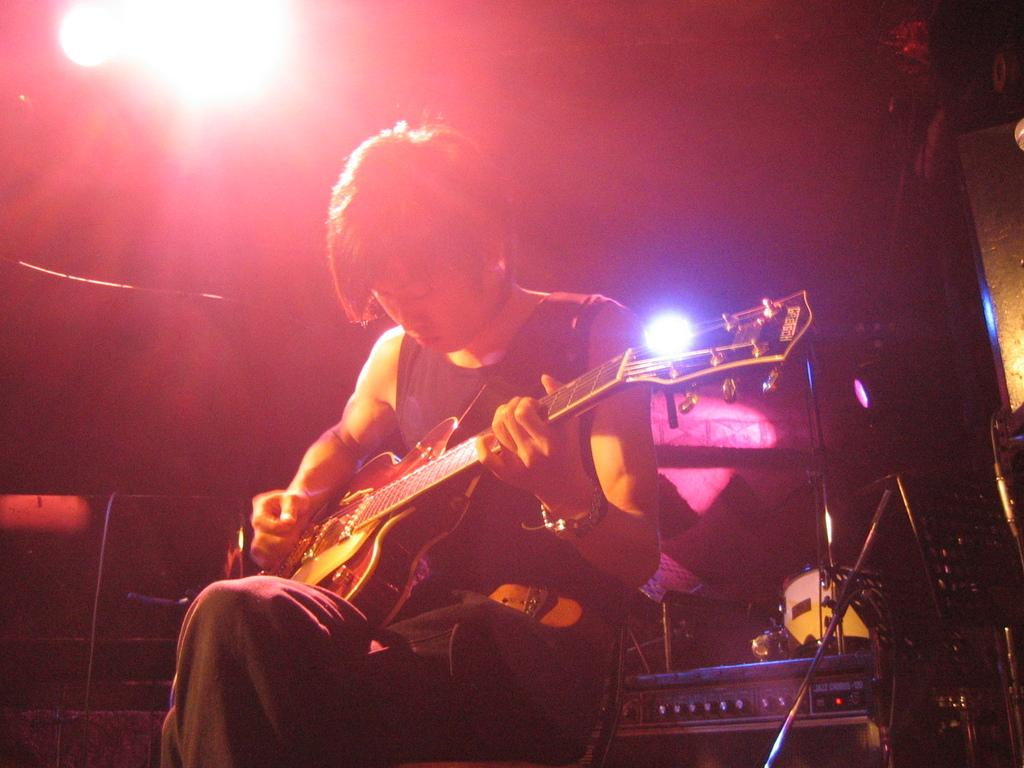What is the main subject of the image? There is a person in the image. What is the person wearing? The person is wearing a black dress. What activity is the person engaged in? The person is playing a guitar. What can be seen in the background of the image? There is a light visible in the background of the image. How many tents are set up in the image? There are no tents present in the image. What type of balls can be seen being juggled by the person in the image? There are no balls visible in the image, and the person is playing a guitar, not juggling. 